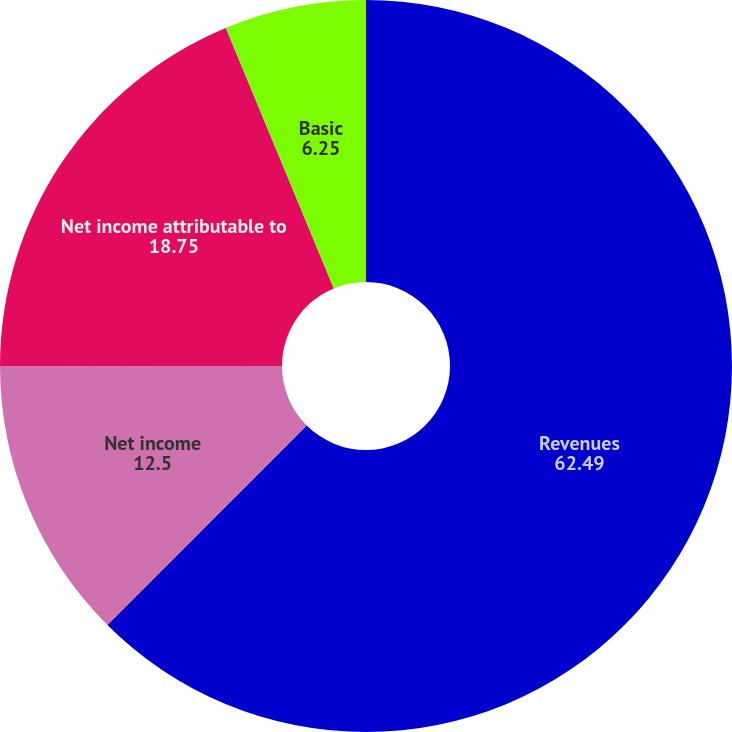<chart> <loc_0><loc_0><loc_500><loc_500><pie_chart><fcel>Revenues<fcel>Net income<fcel>Net income attributable to<fcel>Diluted<fcel>Basic<nl><fcel>62.49%<fcel>12.5%<fcel>18.75%<fcel>0.01%<fcel>6.25%<nl></chart> 